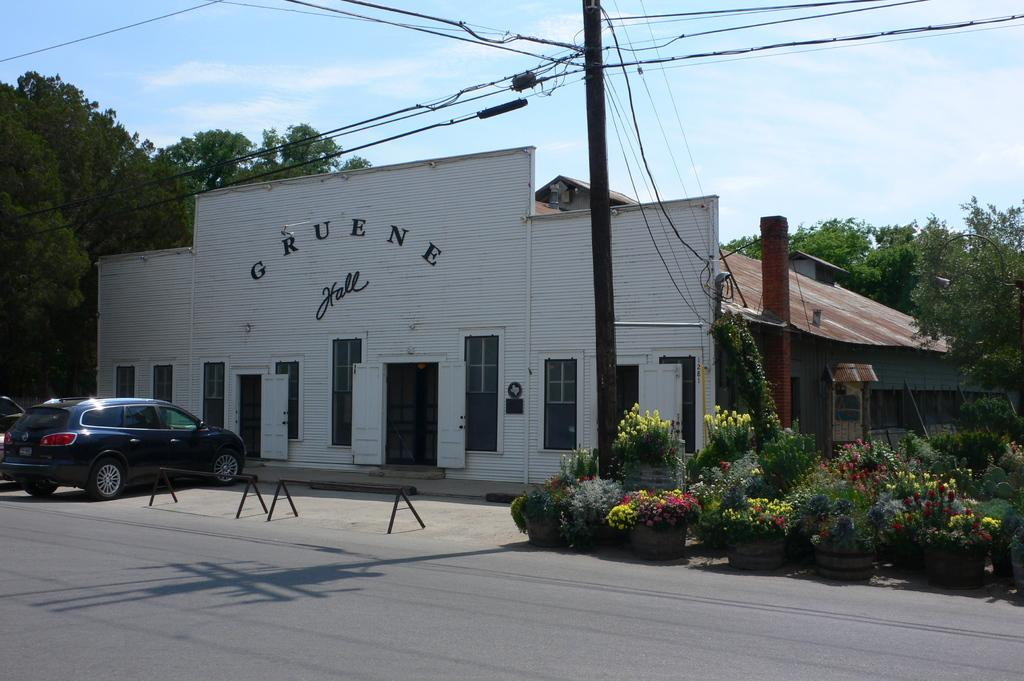What is the main structure in the center of the image? There is a shed in the center of the image. What can be seen in the background of the image? There are trees, a car, and plants visible in the background. What is attached to the pole in the image? There are wires attached to the pole in the image. What type of surface is at the bottom of the image? There is a road at the bottom of the image. What type of memory is being celebrated in the image? There is no indication of a memory or celebration in the image; it primarily features a shed, trees, a car, plants, a pole with wires, and a road. 